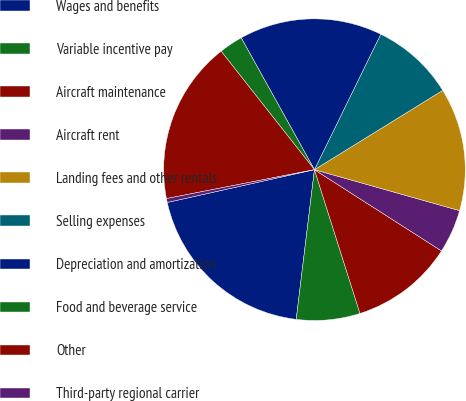Convert chart to OTSL. <chart><loc_0><loc_0><loc_500><loc_500><pie_chart><fcel>Wages and benefits<fcel>Variable incentive pay<fcel>Aircraft maintenance<fcel>Aircraft rent<fcel>Landing fees and other rentals<fcel>Selling expenses<fcel>Depreciation and amortization<fcel>Food and beverage service<fcel>Other<fcel>Third-party regional carrier<nl><fcel>19.58%<fcel>6.81%<fcel>11.06%<fcel>4.68%<fcel>13.19%<fcel>8.94%<fcel>15.32%<fcel>2.55%<fcel>17.45%<fcel>0.42%<nl></chart> 